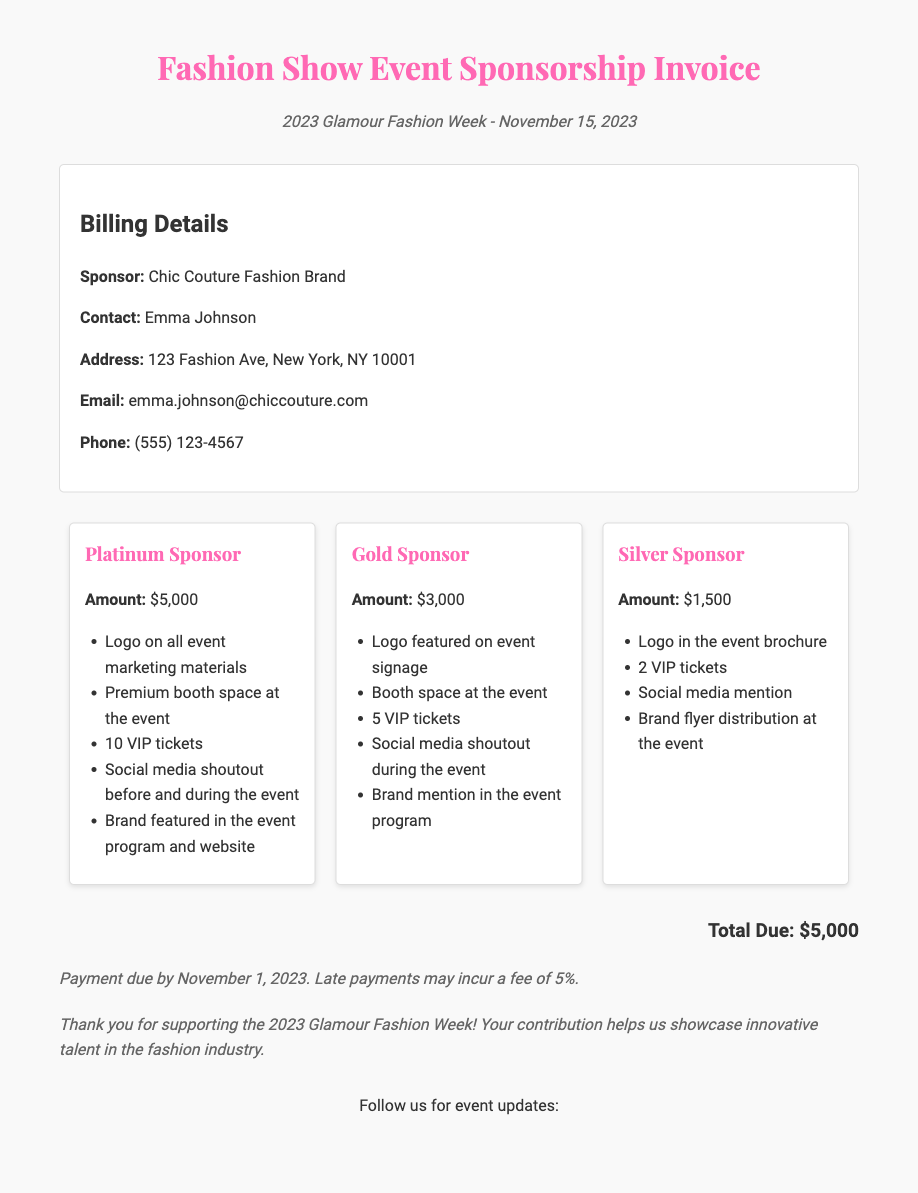what is the title of the event? The title of the event is prominently displayed at the top of the document.
Answer: Fashion Show Event Sponsorship Invoice when is the event date? The event date is mentioned in the event details section of the document.
Answer: November 15, 2023 who is the contact person for the sponsorship? The contact person's name is listed in the billing details section of the document.
Answer: Emma Johnson how much is the Platinum sponsorship level? The Platinum sponsorship amount is clearly stated in the sponsorship levels section.
Answer: $5,000 what benefits does a Gold sponsor receive? The benefits for a Gold sponsor are listed in a bullet format under the Gold sponsorship section.
Answer: Logo featured on event signage, Booth space at the event, 5 VIP tickets, Social media shoutout during the event, Brand mention in the event program what is the total amount due? The total due amount is summarized in the designated section at the bottom of the invoice.
Answer: $5,000 when is the payment due? The payment due date is indicated in the payment terms section of the document.
Answer: November 1, 2023 what is the late payment fee percentage? The late payment fee percentage is mentioned in the payment terms section.
Answer: 5% what social media platforms should sponsors follow for updates? The social media platforms are listed in the social media integration section.
Answer: Facebook, Instagram, Twitter, Pinterest 